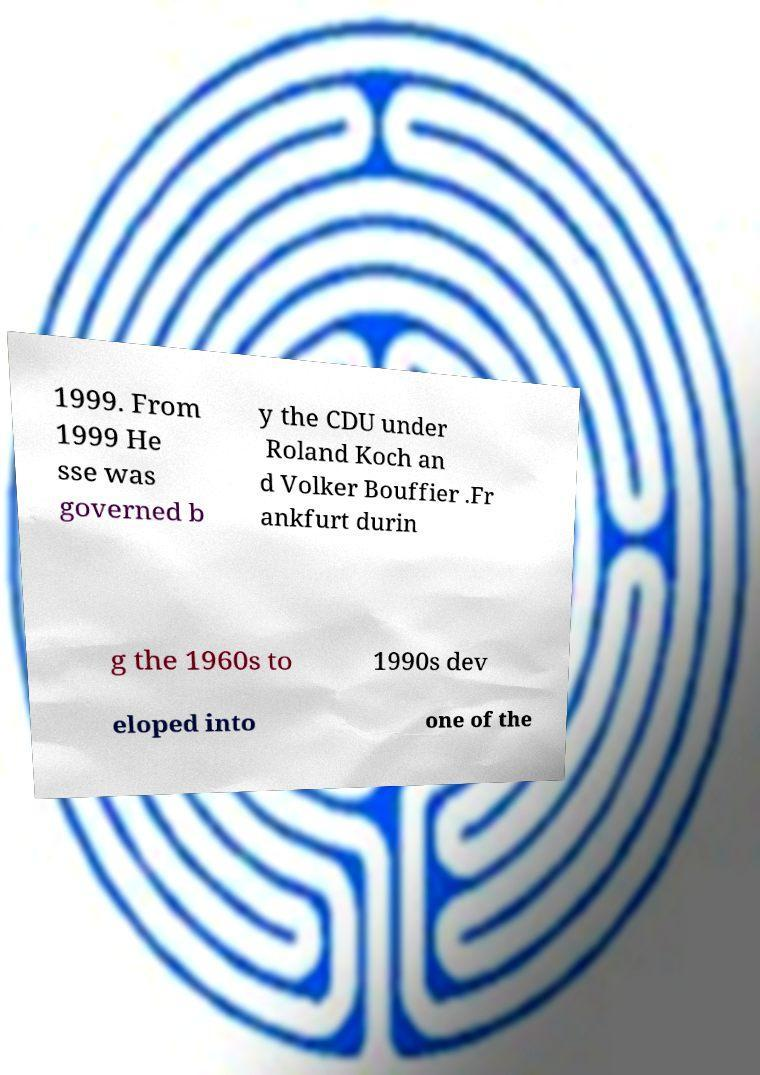Could you assist in decoding the text presented in this image and type it out clearly? 1999. From 1999 He sse was governed b y the CDU under Roland Koch an d Volker Bouffier .Fr ankfurt durin g the 1960s to 1990s dev eloped into one of the 